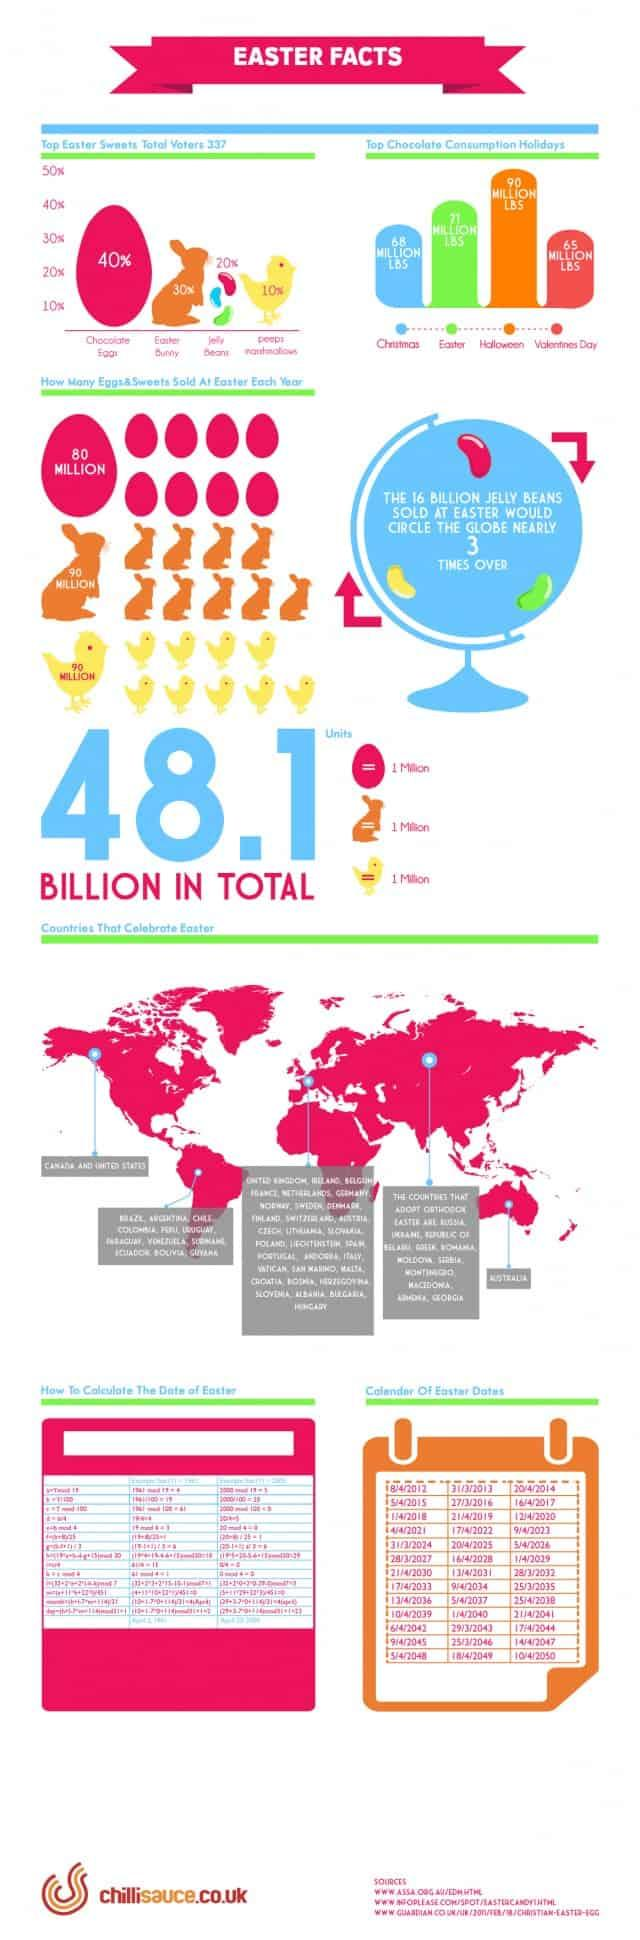Give some essential details in this illustration. The infographic displays three jelly beans. It is estimated that over 90 million Easter Bunnies are sold every Easter. On April 12th, 2030, Easter will be celebrated. Out of 337 people, 135 people voted for chocolate eggs. Easter will be celebrated in March, April, and May of 2032. 